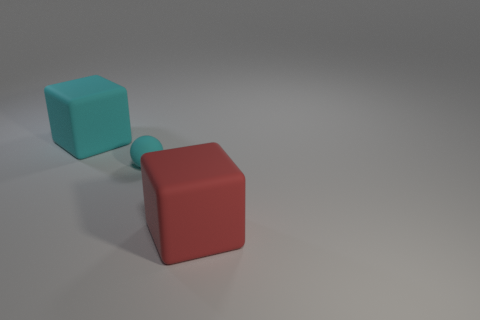Is the size of the rubber cube that is left of the large red rubber thing the same as the red object that is in front of the small ball? yes 